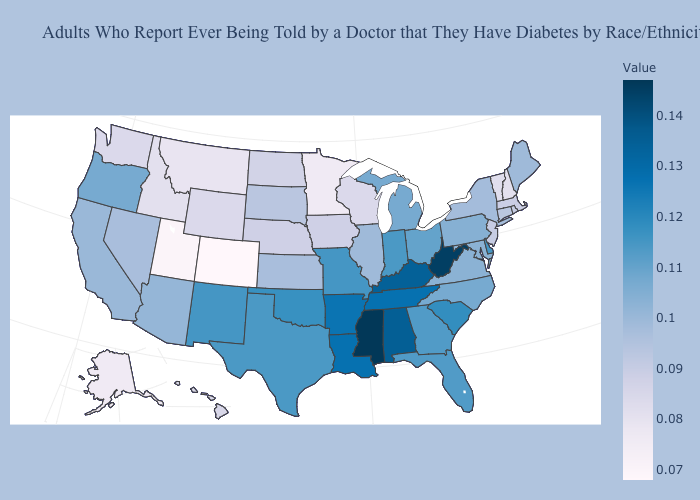Is the legend a continuous bar?
Concise answer only. Yes. Which states have the lowest value in the West?
Quick response, please. Colorado. Which states have the lowest value in the USA?
Short answer required. Colorado. Does New Jersey have the highest value in the USA?
Quick response, please. No. Is the legend a continuous bar?
Short answer required. Yes. Which states have the lowest value in the South?
Short answer required. Maryland, Virginia. 